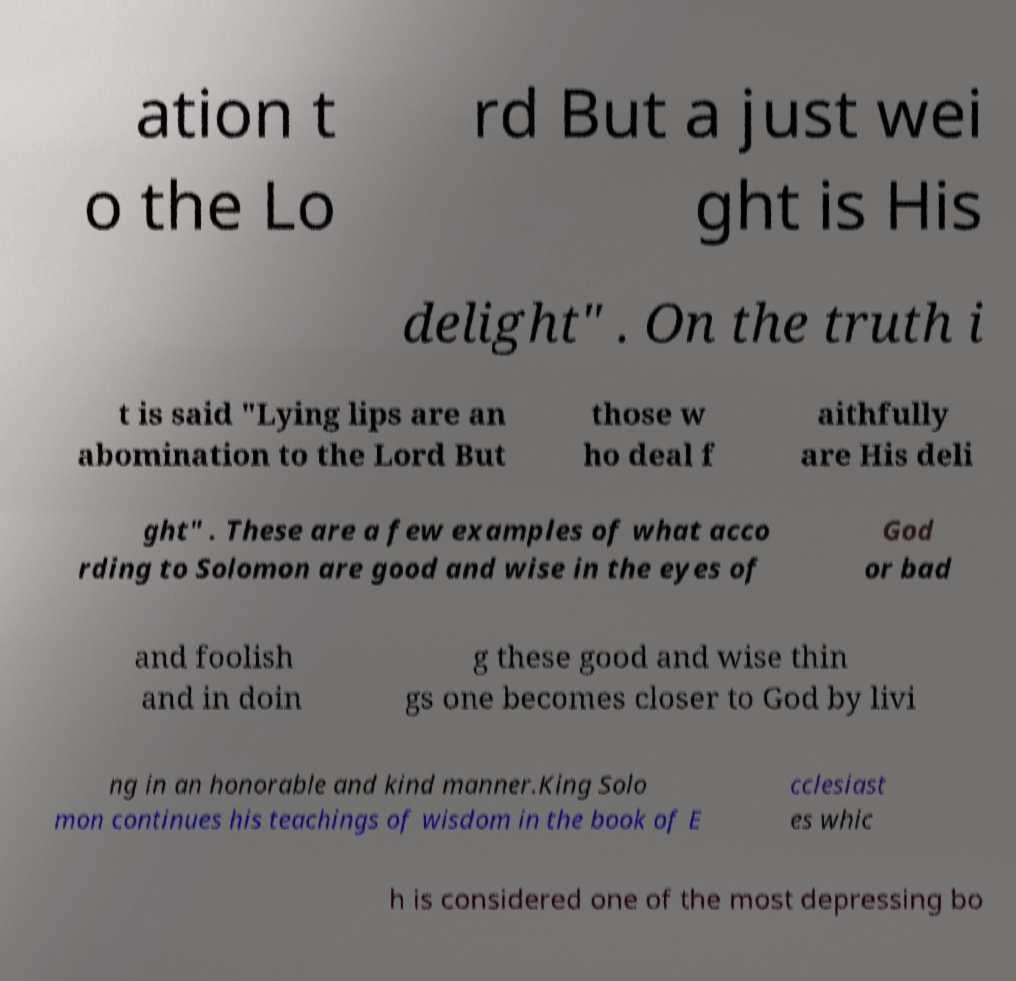I need the written content from this picture converted into text. Can you do that? ation t o the Lo rd But a just wei ght is His delight" . On the truth i t is said "Lying lips are an abomination to the Lord But those w ho deal f aithfully are His deli ght" . These are a few examples of what acco rding to Solomon are good and wise in the eyes of God or bad and foolish and in doin g these good and wise thin gs one becomes closer to God by livi ng in an honorable and kind manner.King Solo mon continues his teachings of wisdom in the book of E cclesiast es whic h is considered one of the most depressing bo 